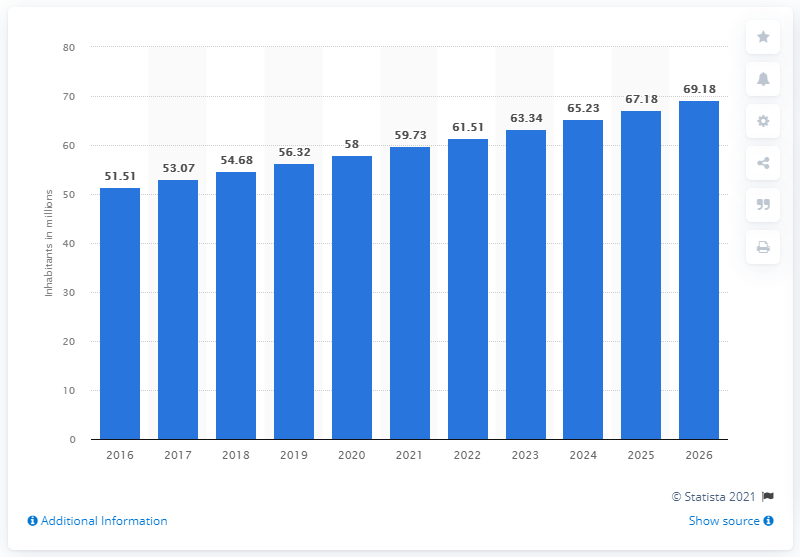Highlight a few significant elements in this photo. According to estimates, the population of Tanzania was approximately 58 million in 2020. 